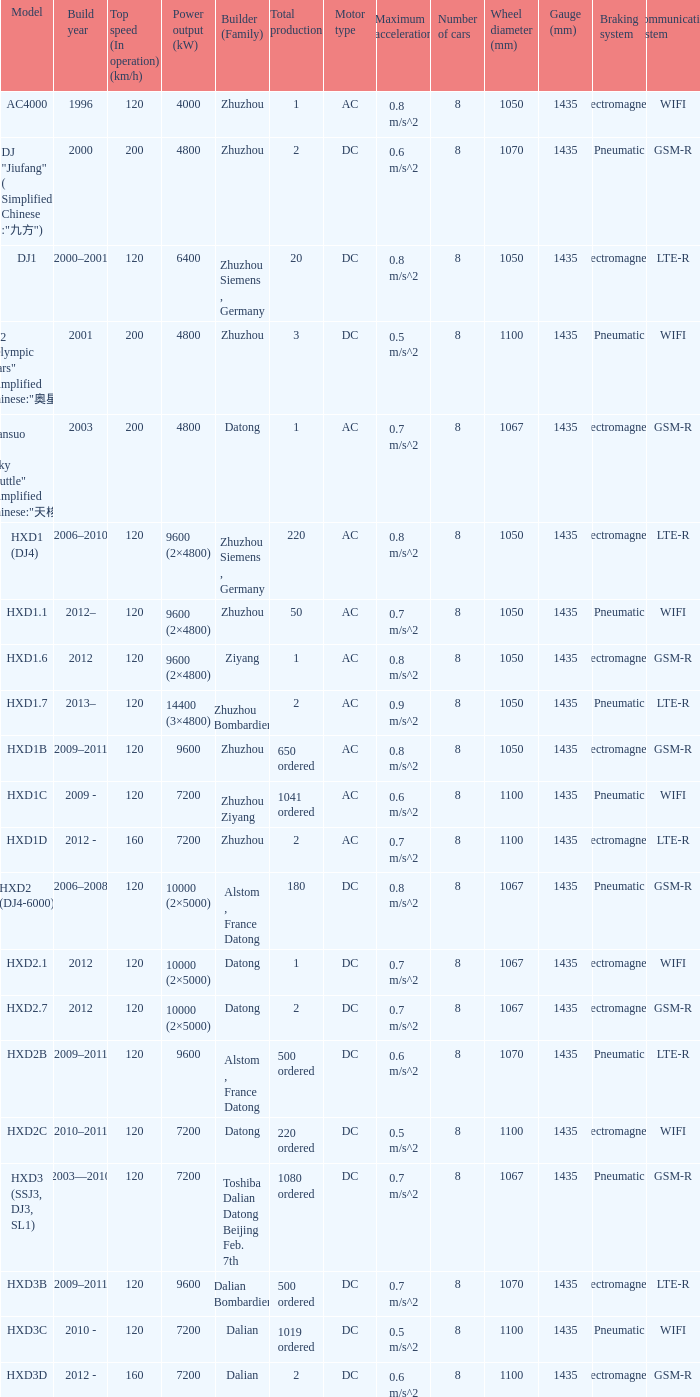What is the power output (kw) of builder zhuzhou, model hxd1d, with a total production of 2? 7200.0. 